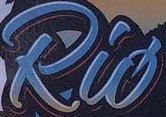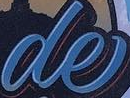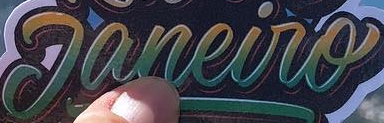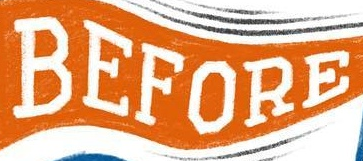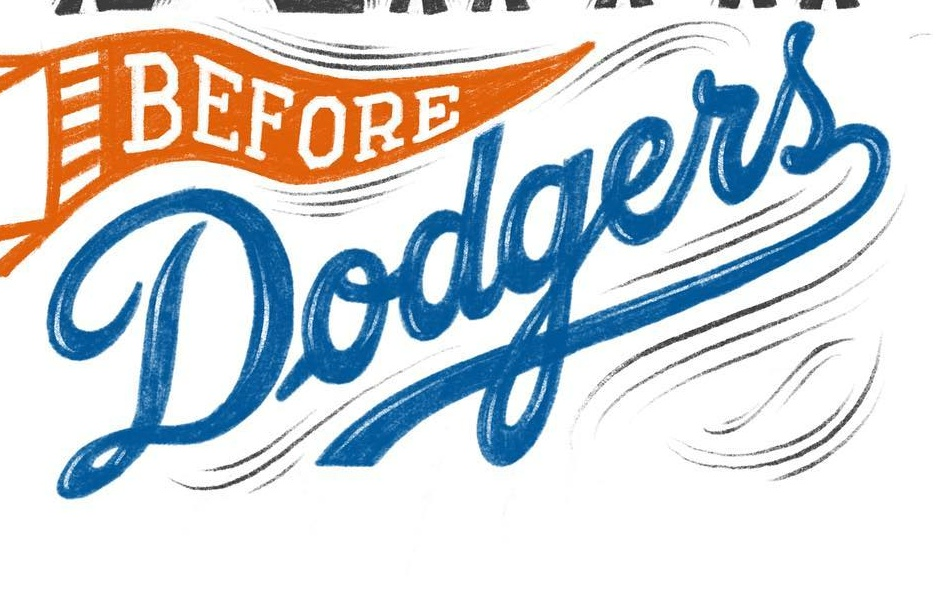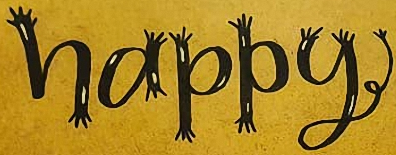What text appears in these images from left to right, separated by a semicolon? Rió; de; Janeiro; BEFORE; Dodgers; happy 